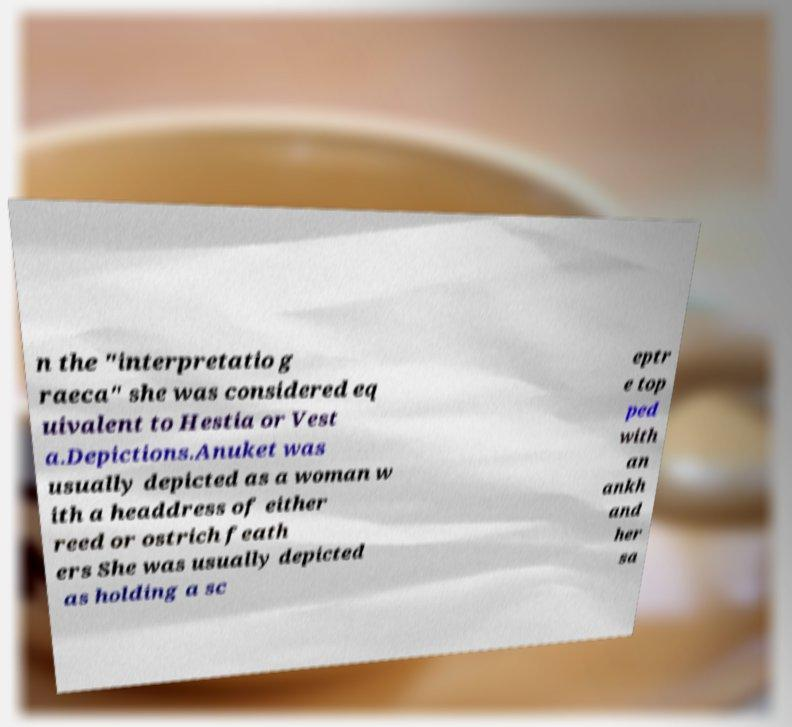Please identify and transcribe the text found in this image. n the "interpretatio g raeca" she was considered eq uivalent to Hestia or Vest a.Depictions.Anuket was usually depicted as a woman w ith a headdress of either reed or ostrich feath ers She was usually depicted as holding a sc eptr e top ped with an ankh and her sa 